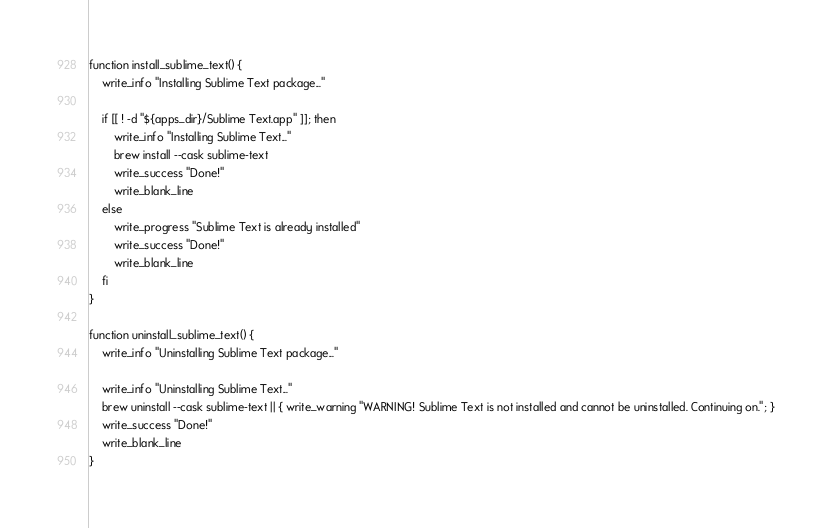Convert code to text. <code><loc_0><loc_0><loc_500><loc_500><_Bash_>function install_sublime_text() {
    write_info "Installing Sublime Text package..."

    if [[ ! -d "${apps_dir}/Sublime Text.app" ]]; then
        write_info "Installing Sublime Text..."
        brew install --cask sublime-text
        write_success "Done!"
        write_blank_line
    else
        write_progress "Sublime Text is already installed"
        write_success "Done!"
        write_blank_line
    fi
}

function uninstall_sublime_text() {
    write_info "Uninstalling Sublime Text package..."

    write_info "Uninstalling Sublime Text..."
    brew uninstall --cask sublime-text || { write_warning "WARNING! Sublime Text is not installed and cannot be uninstalled. Continuing on."; }
    write_success "Done!"
    write_blank_line
}
</code> 